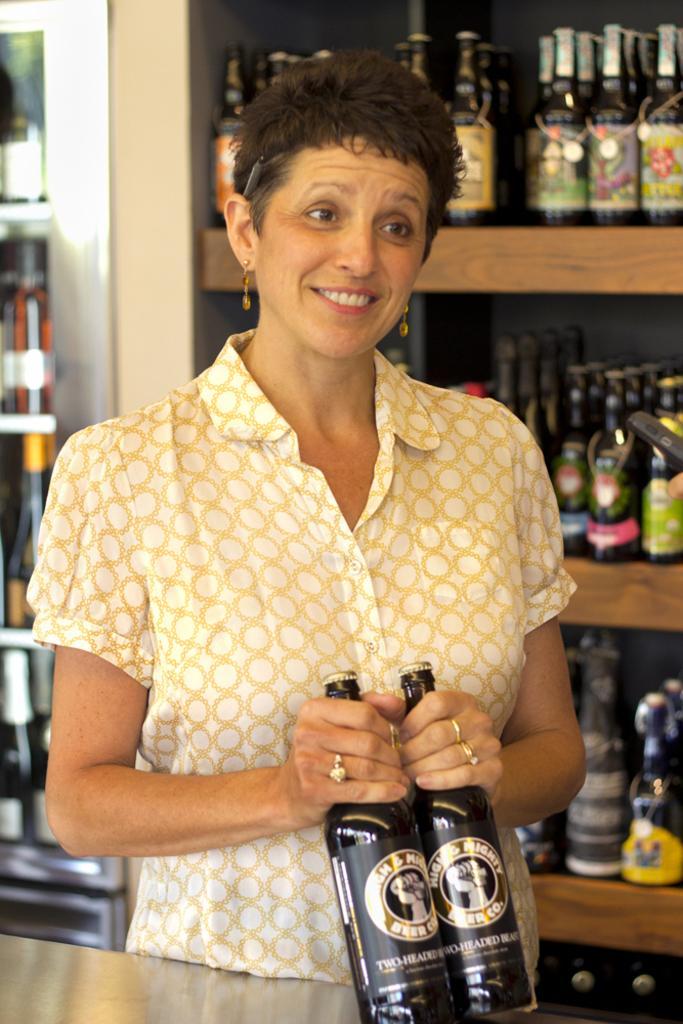Can you describe this image briefly? In this picture we can see a woman standing and holding a wine bottle in her hand, and in front here is the table, and at the back side there are many wine bottle in the rack. 